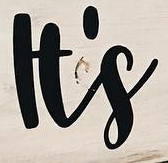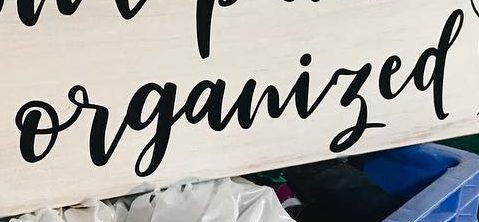Read the text content from these images in order, separated by a semicolon. It's; organized 